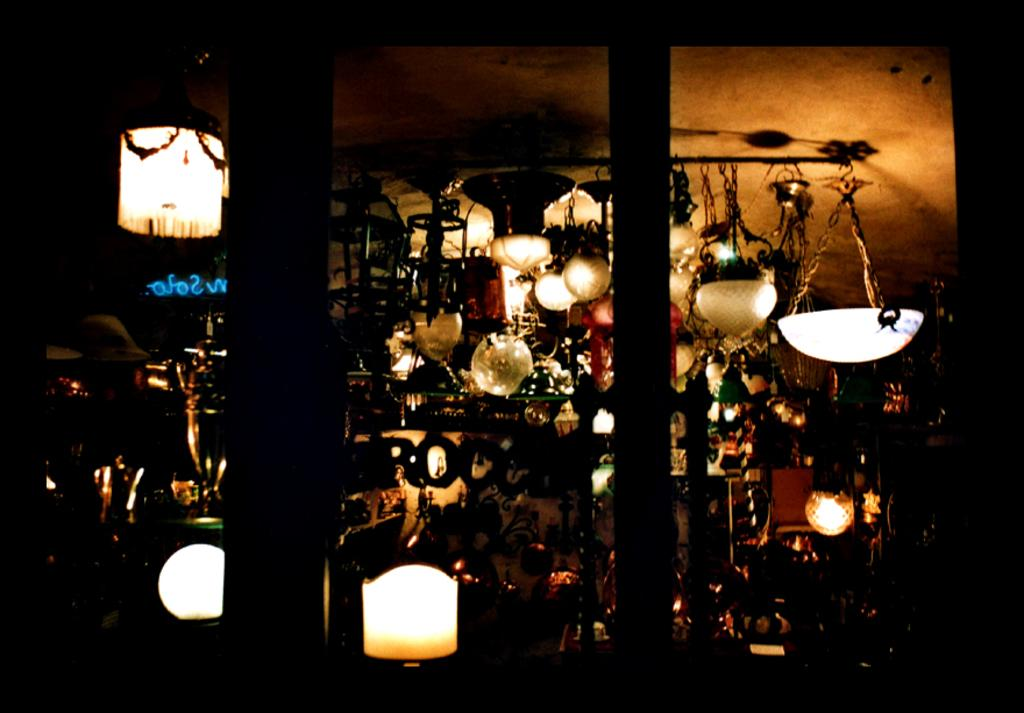What type of lighting is present in the image? There are lamps hanging from the ceiling in the image. Can you describe any other objects in the image besides the lamps? Unfortunately, the provided facts only mention that there are some objects in the image, but no specific details are given. What type of legal advice can be obtained from the bean in the image? There is no bean present in the image, and therefore no legal advice can be obtained from it. 